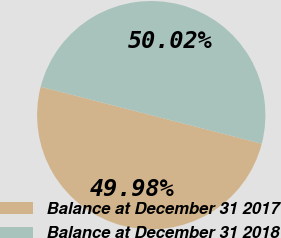Convert chart to OTSL. <chart><loc_0><loc_0><loc_500><loc_500><pie_chart><fcel>Balance at December 31 2017<fcel>Balance at December 31 2018<nl><fcel>49.98%<fcel>50.02%<nl></chart> 